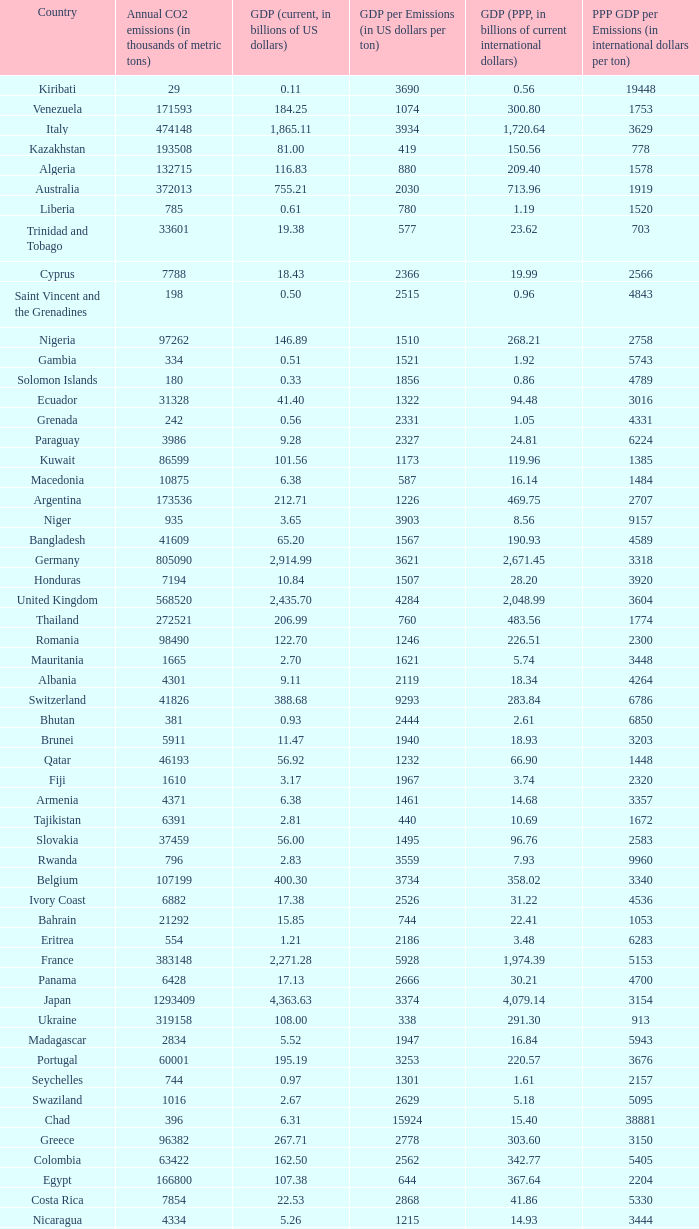When the gdp (ppp, in billions of current international dollars) is 7.93, what is the maximum ppp gdp per emissions (in international dollars per ton)? 9960.0. 